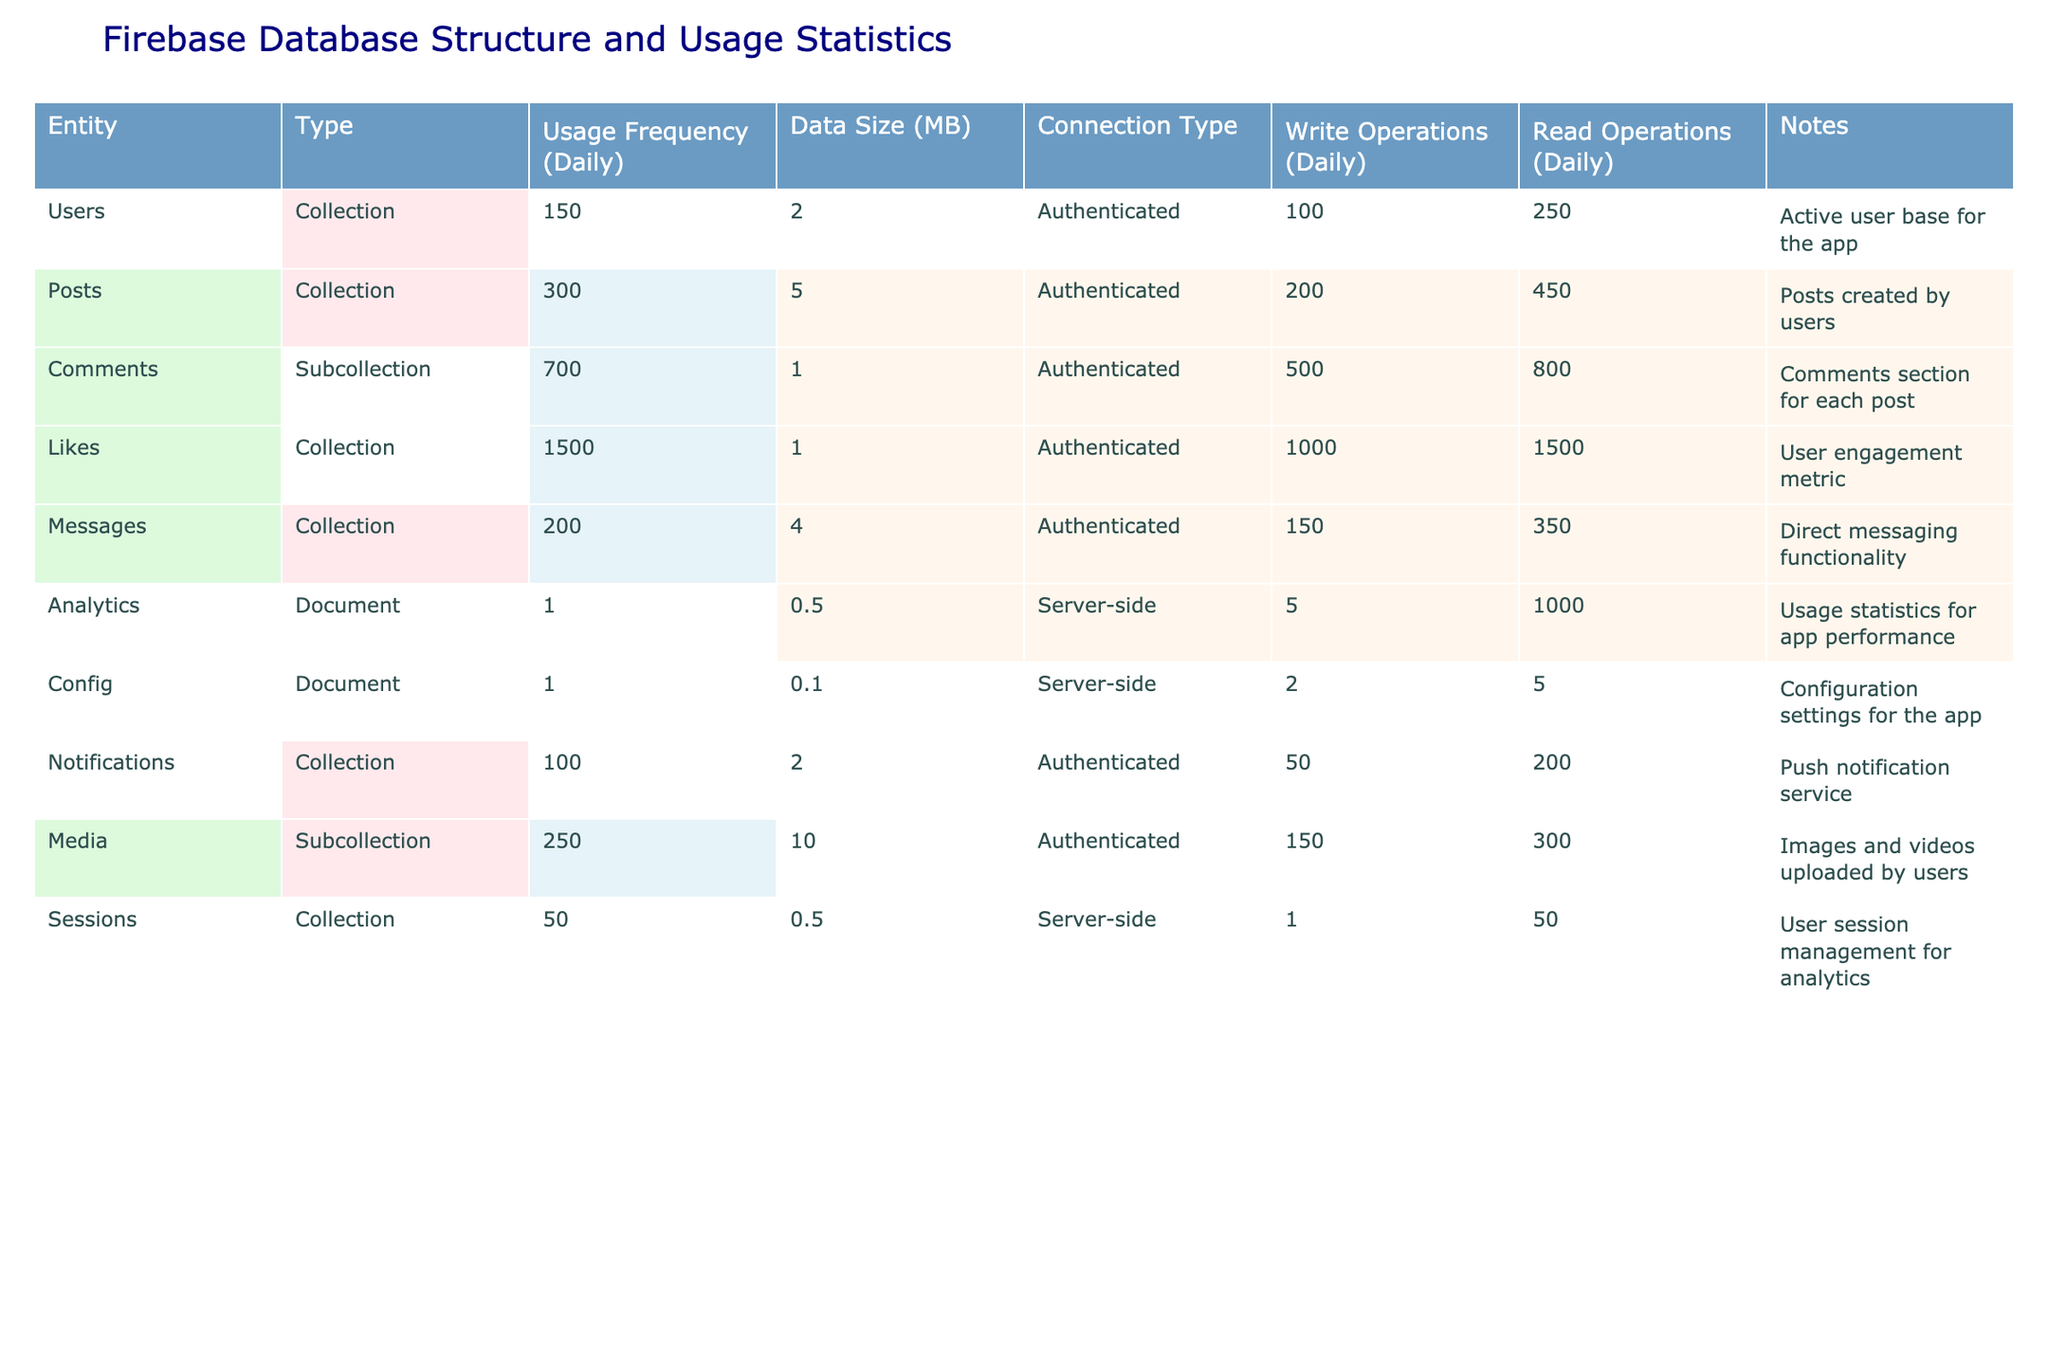What is the most frequently used entity in the Firebase database? The usage frequency values for each entity are listed. I identify the highest value, which is 1500 for Likes.
Answer: Likes How many write operations does the Comments entity have daily? The write operations for Comments are stated in the table, and they are 500 per day.
Answer: 500 What is the average data size of all entities in MB? To find the average, I sum the data sizes: (2 + 5 + 1 + 1 + 4 + 0.5 + 0.1 + 2 + 10 + 0.5) = 26.2 MB. There are 10 entities, thus the average is 26.2 / 10 = 2.62 MB.
Answer: 2.62 True or False: The Analytics document has a data size larger than the Config document. From the table, the data size for Analytics is 0.5 MB and for Config is 0.1 MB. Thus, Analytics has a larger size than Config, making the statement true.
Answer: True Which collection has the highest read operations and what is the value? By comparing the read operations for all entities, I see that Likes has the highest at 1500 read operations daily.
Answer: Likes, 1500 What is the total number of read operations across all entities? I calculate the total by adding all read operations: 250 + 450 + 800 + 1500 + 350 + 1000 + 5 + 200 + 300 + 50 = 3855.
Answer: 3855 Is the total write operations for Users and Messages greater than the write operations for Likes? The write operations for Users are 100, Messages are 150, and Likes are 1000. Summing Users and Messages gives 250, which is less than Likes' 1000. So, the statement is false.
Answer: False What percentage of total daily usage frequency is from the Posts collection? The total usage frequency sums to 3000. The Posts have 300. I calculate (300 / 3000) * 100% = 10%.
Answer: 10% Identify the Collections that have a data size greater than the average data size. The average data size is 2.62 MB. The Collections with more data are Posts (5 MB), Media (10 MB), and Messages (4 MB).
Answer: Posts, Media, Messages Which entity has the lowest daily write operations? I look for the smallest value in the write operations column and find Sessions with only 1 daily write operation.
Answer: Sessions 